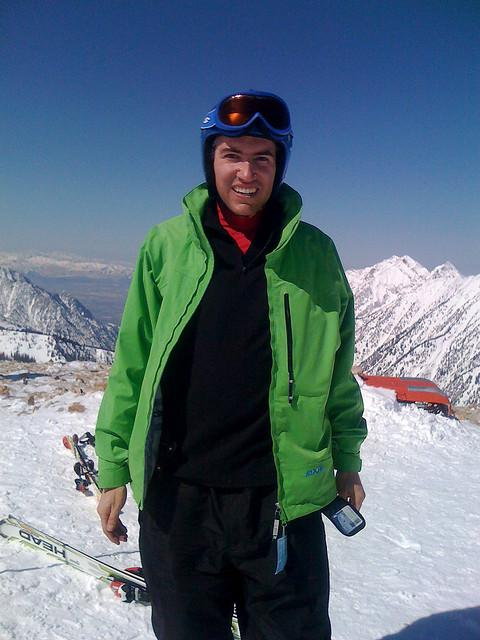What type of telephone is he using? cellphone 